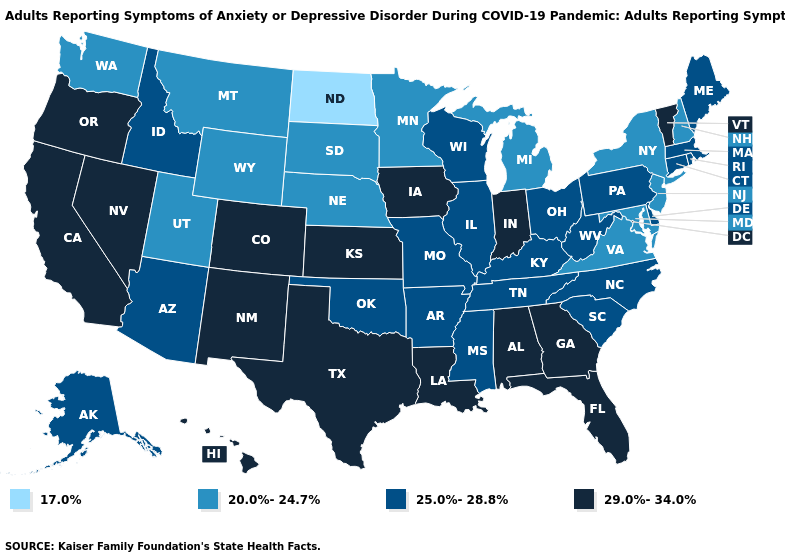What is the highest value in the USA?
Keep it brief. 29.0%-34.0%. Name the states that have a value in the range 29.0%-34.0%?
Be succinct. Alabama, California, Colorado, Florida, Georgia, Hawaii, Indiana, Iowa, Kansas, Louisiana, Nevada, New Mexico, Oregon, Texas, Vermont. What is the value of California?
Short answer required. 29.0%-34.0%. Is the legend a continuous bar?
Keep it brief. No. What is the value of Minnesota?
Give a very brief answer. 20.0%-24.7%. What is the lowest value in the USA?
Keep it brief. 17.0%. What is the value of North Dakota?
Write a very short answer. 17.0%. Name the states that have a value in the range 25.0%-28.8%?
Answer briefly. Alaska, Arizona, Arkansas, Connecticut, Delaware, Idaho, Illinois, Kentucky, Maine, Massachusetts, Mississippi, Missouri, North Carolina, Ohio, Oklahoma, Pennsylvania, Rhode Island, South Carolina, Tennessee, West Virginia, Wisconsin. Name the states that have a value in the range 29.0%-34.0%?
Short answer required. Alabama, California, Colorado, Florida, Georgia, Hawaii, Indiana, Iowa, Kansas, Louisiana, Nevada, New Mexico, Oregon, Texas, Vermont. What is the value of Texas?
Keep it brief. 29.0%-34.0%. How many symbols are there in the legend?
Short answer required. 4. What is the value of Iowa?
Keep it brief. 29.0%-34.0%. What is the highest value in the West ?
Short answer required. 29.0%-34.0%. Among the states that border Montana , which have the highest value?
Keep it brief. Idaho. Among the states that border Kansas , which have the lowest value?
Concise answer only. Nebraska. 